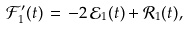Convert formula to latex. <formula><loc_0><loc_0><loc_500><loc_500>\mathcal { F } _ { 1 } ^ { \prime } ( t ) \, = \, - 2 \, \mathcal { E } _ { 1 } ( t ) + \mathcal { R } _ { 1 } ( t ) ,</formula> 